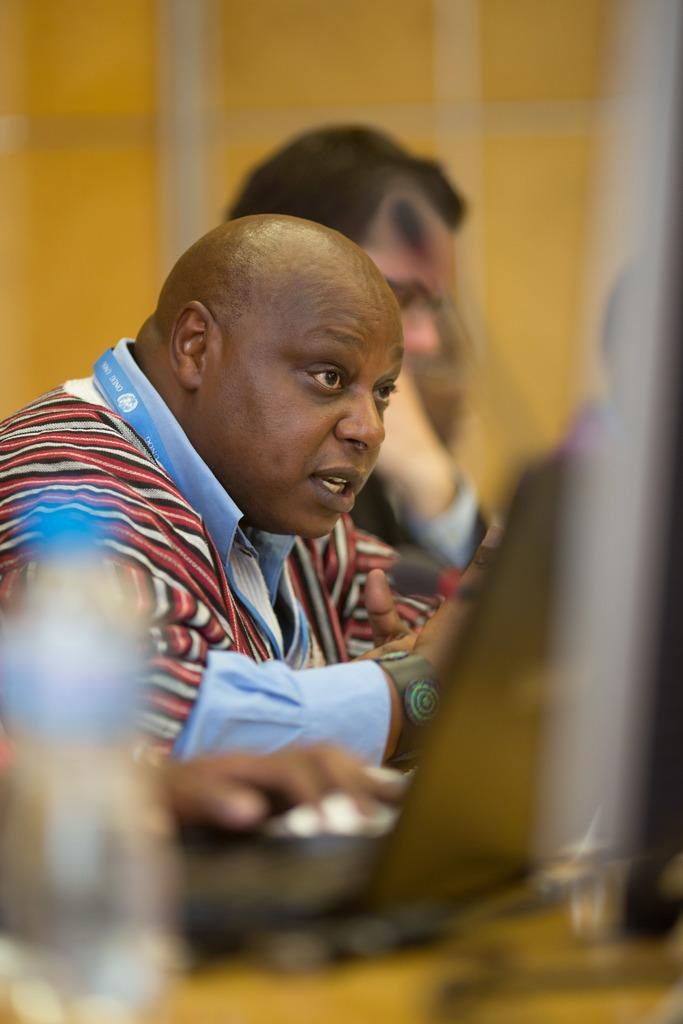What is located at the bottom left side of the image? There is a blurred picture of a bottle at the bottom left side of the image. What can be seen in the middle of the image? There are two persons sitting in the middle of the image. What type of insect can be seen flying around the bottle in the image? There is no insect present in the image; it only shows a blurred picture of a bottle and two persons sitting. 